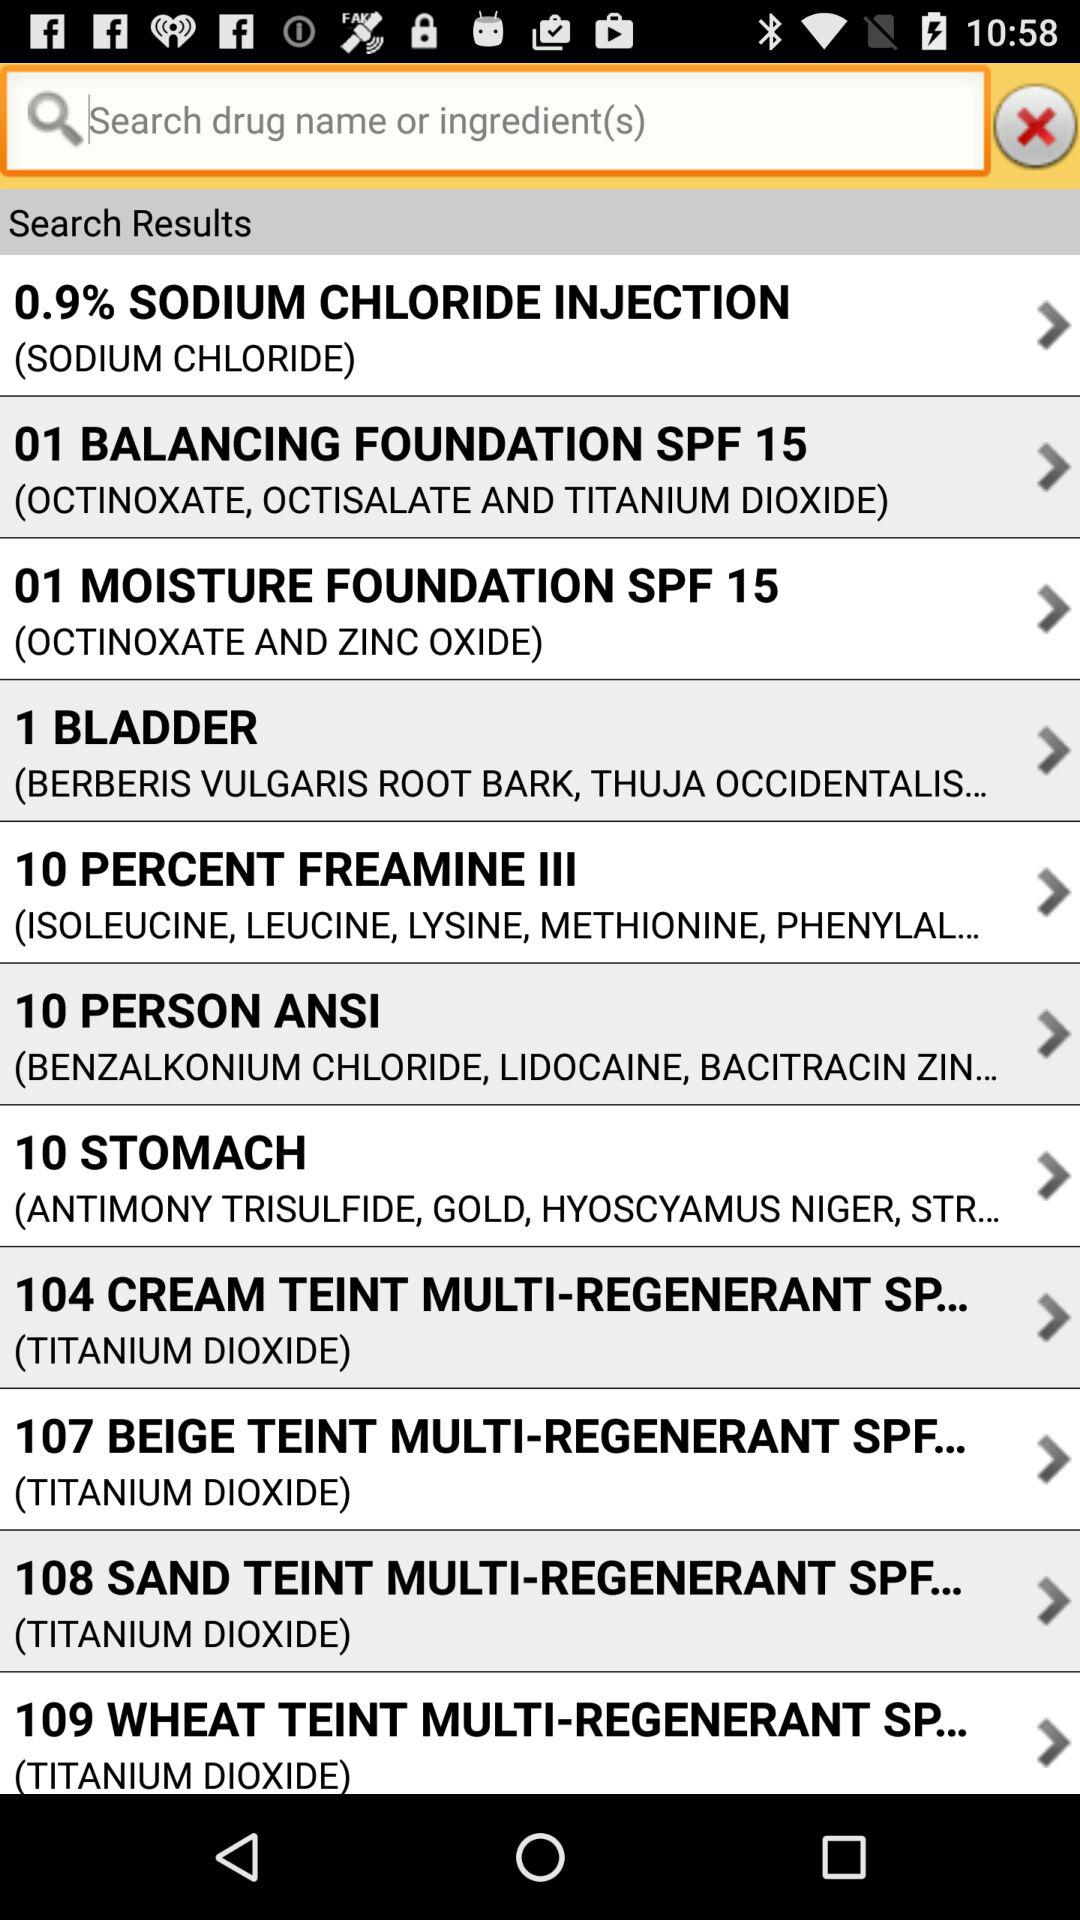What are the ingredients in "10 PERCENT FREAMINE III"? The ingredients are isoleucine, leucine, lysine, methionine and "PHENYLAL...". 